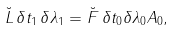<formula> <loc_0><loc_0><loc_500><loc_500>\breve { L } \, \delta t _ { 1 } \, \delta \lambda _ { 1 } = \breve { F } \, \delta t _ { 0 } \delta \lambda _ { 0 } A _ { 0 } ,</formula> 